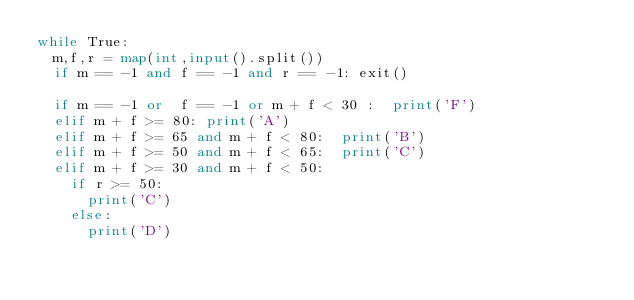<code> <loc_0><loc_0><loc_500><loc_500><_Python_>while True:
  m,f,r = map(int,input().split())
  if m == -1 and f == -1 and r == -1: exit()

  if m == -1 or  f == -1 or m + f < 30 :  print('F')
  elif m + f >= 80: print('A')
  elif m + f >= 65 and m + f < 80:  print('B')
  elif m + f >= 50 and m + f < 65:  print('C')
  elif m + f >= 30 and m + f < 50:
    if r >= 50:
      print('C')
    else:
      print('D')
</code> 